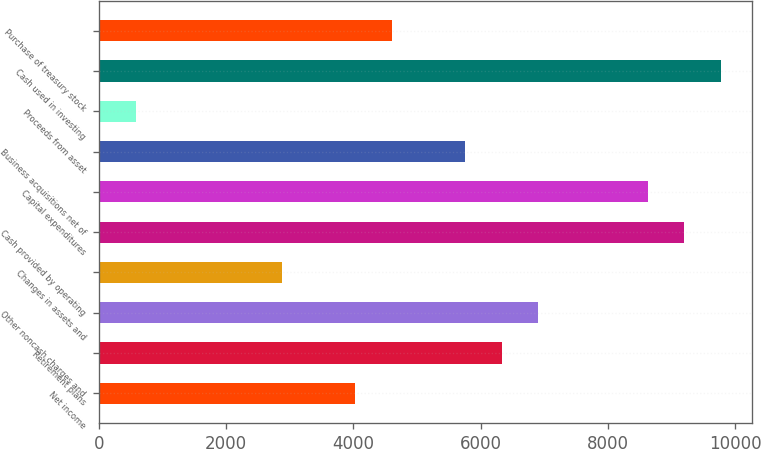Convert chart to OTSL. <chart><loc_0><loc_0><loc_500><loc_500><bar_chart><fcel>Net income<fcel>Retirement plans<fcel>Other noncash charges and<fcel>Changes in assets and<fcel>Cash provided by operating<fcel>Capital expenditures<fcel>Business acquisitions net of<fcel>Proceeds from asset<fcel>Cash used in investing<fcel>Purchase of treasury stock<nl><fcel>4027.9<fcel>6326.7<fcel>6901.4<fcel>2878.5<fcel>9200.2<fcel>8625.5<fcel>5752<fcel>579.7<fcel>9774.9<fcel>4602.6<nl></chart> 